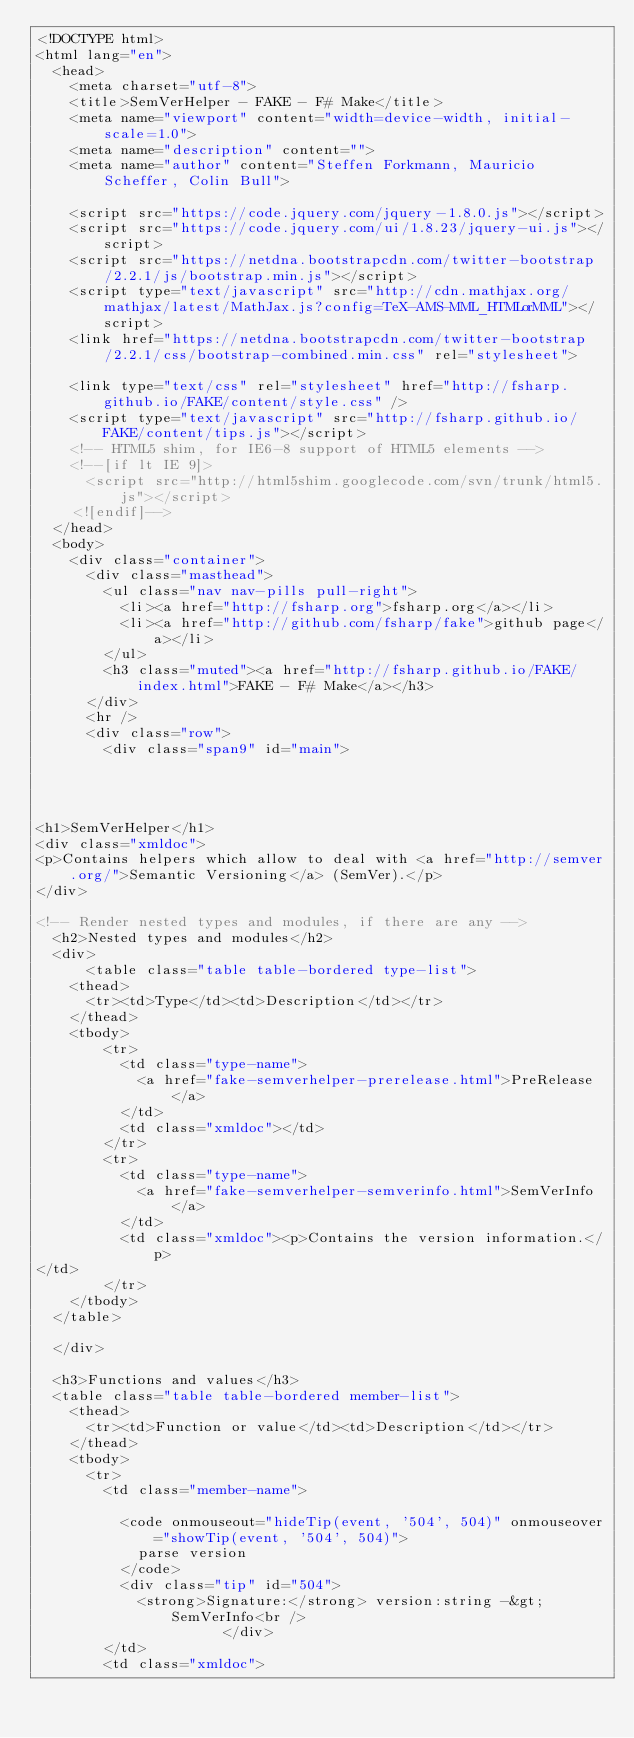Convert code to text. <code><loc_0><loc_0><loc_500><loc_500><_HTML_><!DOCTYPE html>
<html lang="en">
  <head>
    <meta charset="utf-8">
    <title>SemVerHelper - FAKE - F# Make</title>
    <meta name="viewport" content="width=device-width, initial-scale=1.0">
    <meta name="description" content="">
    <meta name="author" content="Steffen Forkmann, Mauricio Scheffer, Colin Bull">

    <script src="https://code.jquery.com/jquery-1.8.0.js"></script>
    <script src="https://code.jquery.com/ui/1.8.23/jquery-ui.js"></script>
    <script src="https://netdna.bootstrapcdn.com/twitter-bootstrap/2.2.1/js/bootstrap.min.js"></script>
    <script type="text/javascript" src="http://cdn.mathjax.org/mathjax/latest/MathJax.js?config=TeX-AMS-MML_HTMLorMML"></script>
    <link href="https://netdna.bootstrapcdn.com/twitter-bootstrap/2.2.1/css/bootstrap-combined.min.css" rel="stylesheet">

    <link type="text/css" rel="stylesheet" href="http://fsharp.github.io/FAKE/content/style.css" />
    <script type="text/javascript" src="http://fsharp.github.io/FAKE/content/tips.js"></script>
    <!-- HTML5 shim, for IE6-8 support of HTML5 elements -->
    <!--[if lt IE 9]>
      <script src="http://html5shim.googlecode.com/svn/trunk/html5.js"></script>
    <![endif]-->
  </head>
  <body>
    <div class="container">
      <div class="masthead">
        <ul class="nav nav-pills pull-right">
          <li><a href="http://fsharp.org">fsharp.org</a></li>
          <li><a href="http://github.com/fsharp/fake">github page</a></li>
        </ul>
        <h3 class="muted"><a href="http://fsharp.github.io/FAKE/index.html">FAKE - F# Make</a></h3>
      </div>
      <hr />
      <div class="row">
        <div class="span9" id="main">
          



<h1>SemVerHelper</h1>
<div class="xmldoc">
<p>Contains helpers which allow to deal with <a href="http://semver.org/">Semantic Versioning</a> (SemVer).</p>
</div>

<!-- Render nested types and modules, if there are any -->
  <h2>Nested types and modules</h2>
  <div>
      <table class="table table-bordered type-list">
    <thead>
      <tr><td>Type</td><td>Description</td></tr>
    </thead>
    <tbody>
        <tr>
          <td class="type-name">
            <a href="fake-semverhelper-prerelease.html">PreRelease</a>
          </td>
          <td class="xmldoc"></td>
        </tr>
        <tr>
          <td class="type-name">
            <a href="fake-semverhelper-semverinfo.html">SemVerInfo</a>
          </td>
          <td class="xmldoc"><p>Contains the version information.</p>
</td>
        </tr>
    </tbody>
  </table>

  </div>

  <h3>Functions and values</h3>
  <table class="table table-bordered member-list">
    <thead>
      <tr><td>Function or value</td><td>Description</td></tr>
    </thead>
    <tbody>
      <tr>
        <td class="member-name">

          <code onmouseout="hideTip(event, '504', 504)" onmouseover="showTip(event, '504', 504)">
            parse version
          </code>
          <div class="tip" id="504">
            <strong>Signature:</strong> version:string -&gt; SemVerInfo<br />
                      </div>
        </td>
        <td class="xmldoc"></code> 